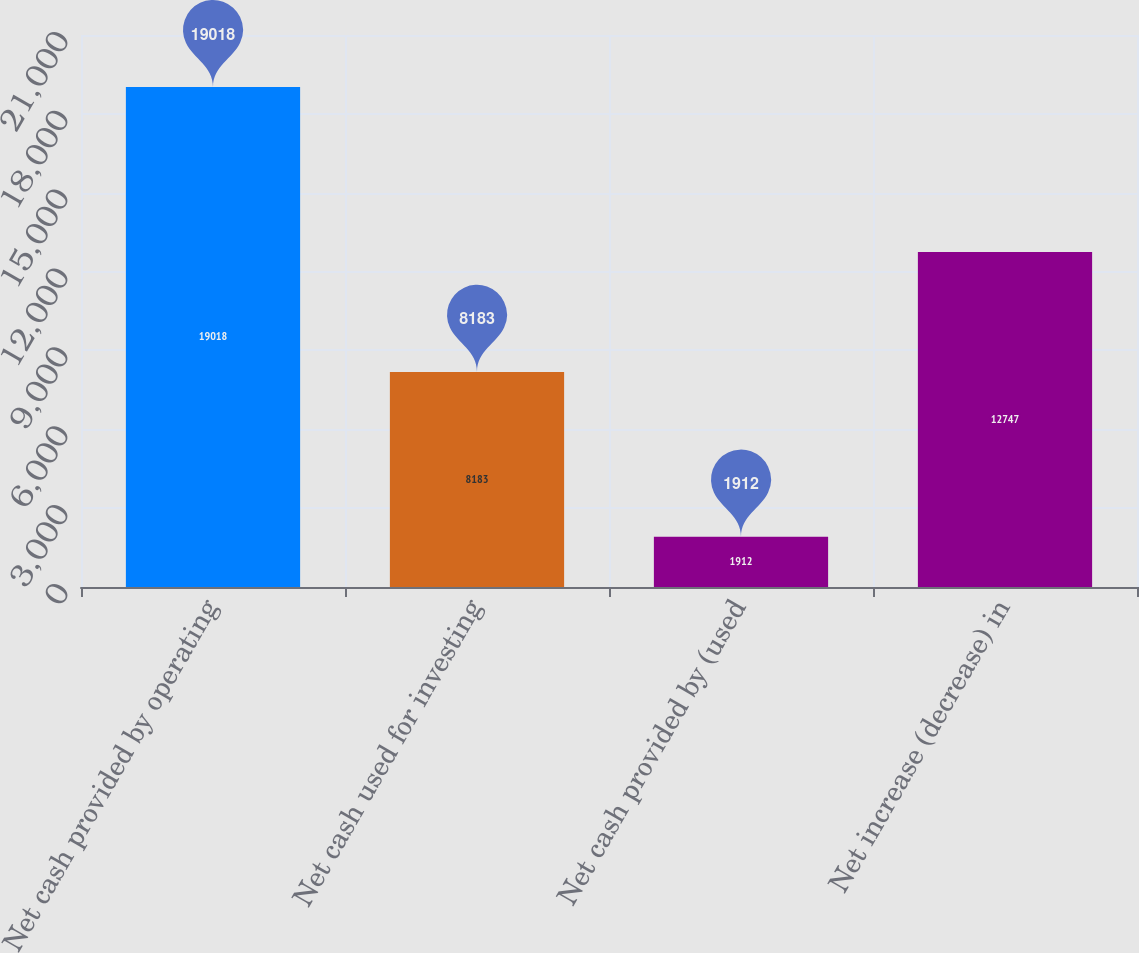<chart> <loc_0><loc_0><loc_500><loc_500><bar_chart><fcel>Net cash provided by operating<fcel>Net cash used for investing<fcel>Net cash provided by (used<fcel>Net increase (decrease) in<nl><fcel>19018<fcel>8183<fcel>1912<fcel>12747<nl></chart> 